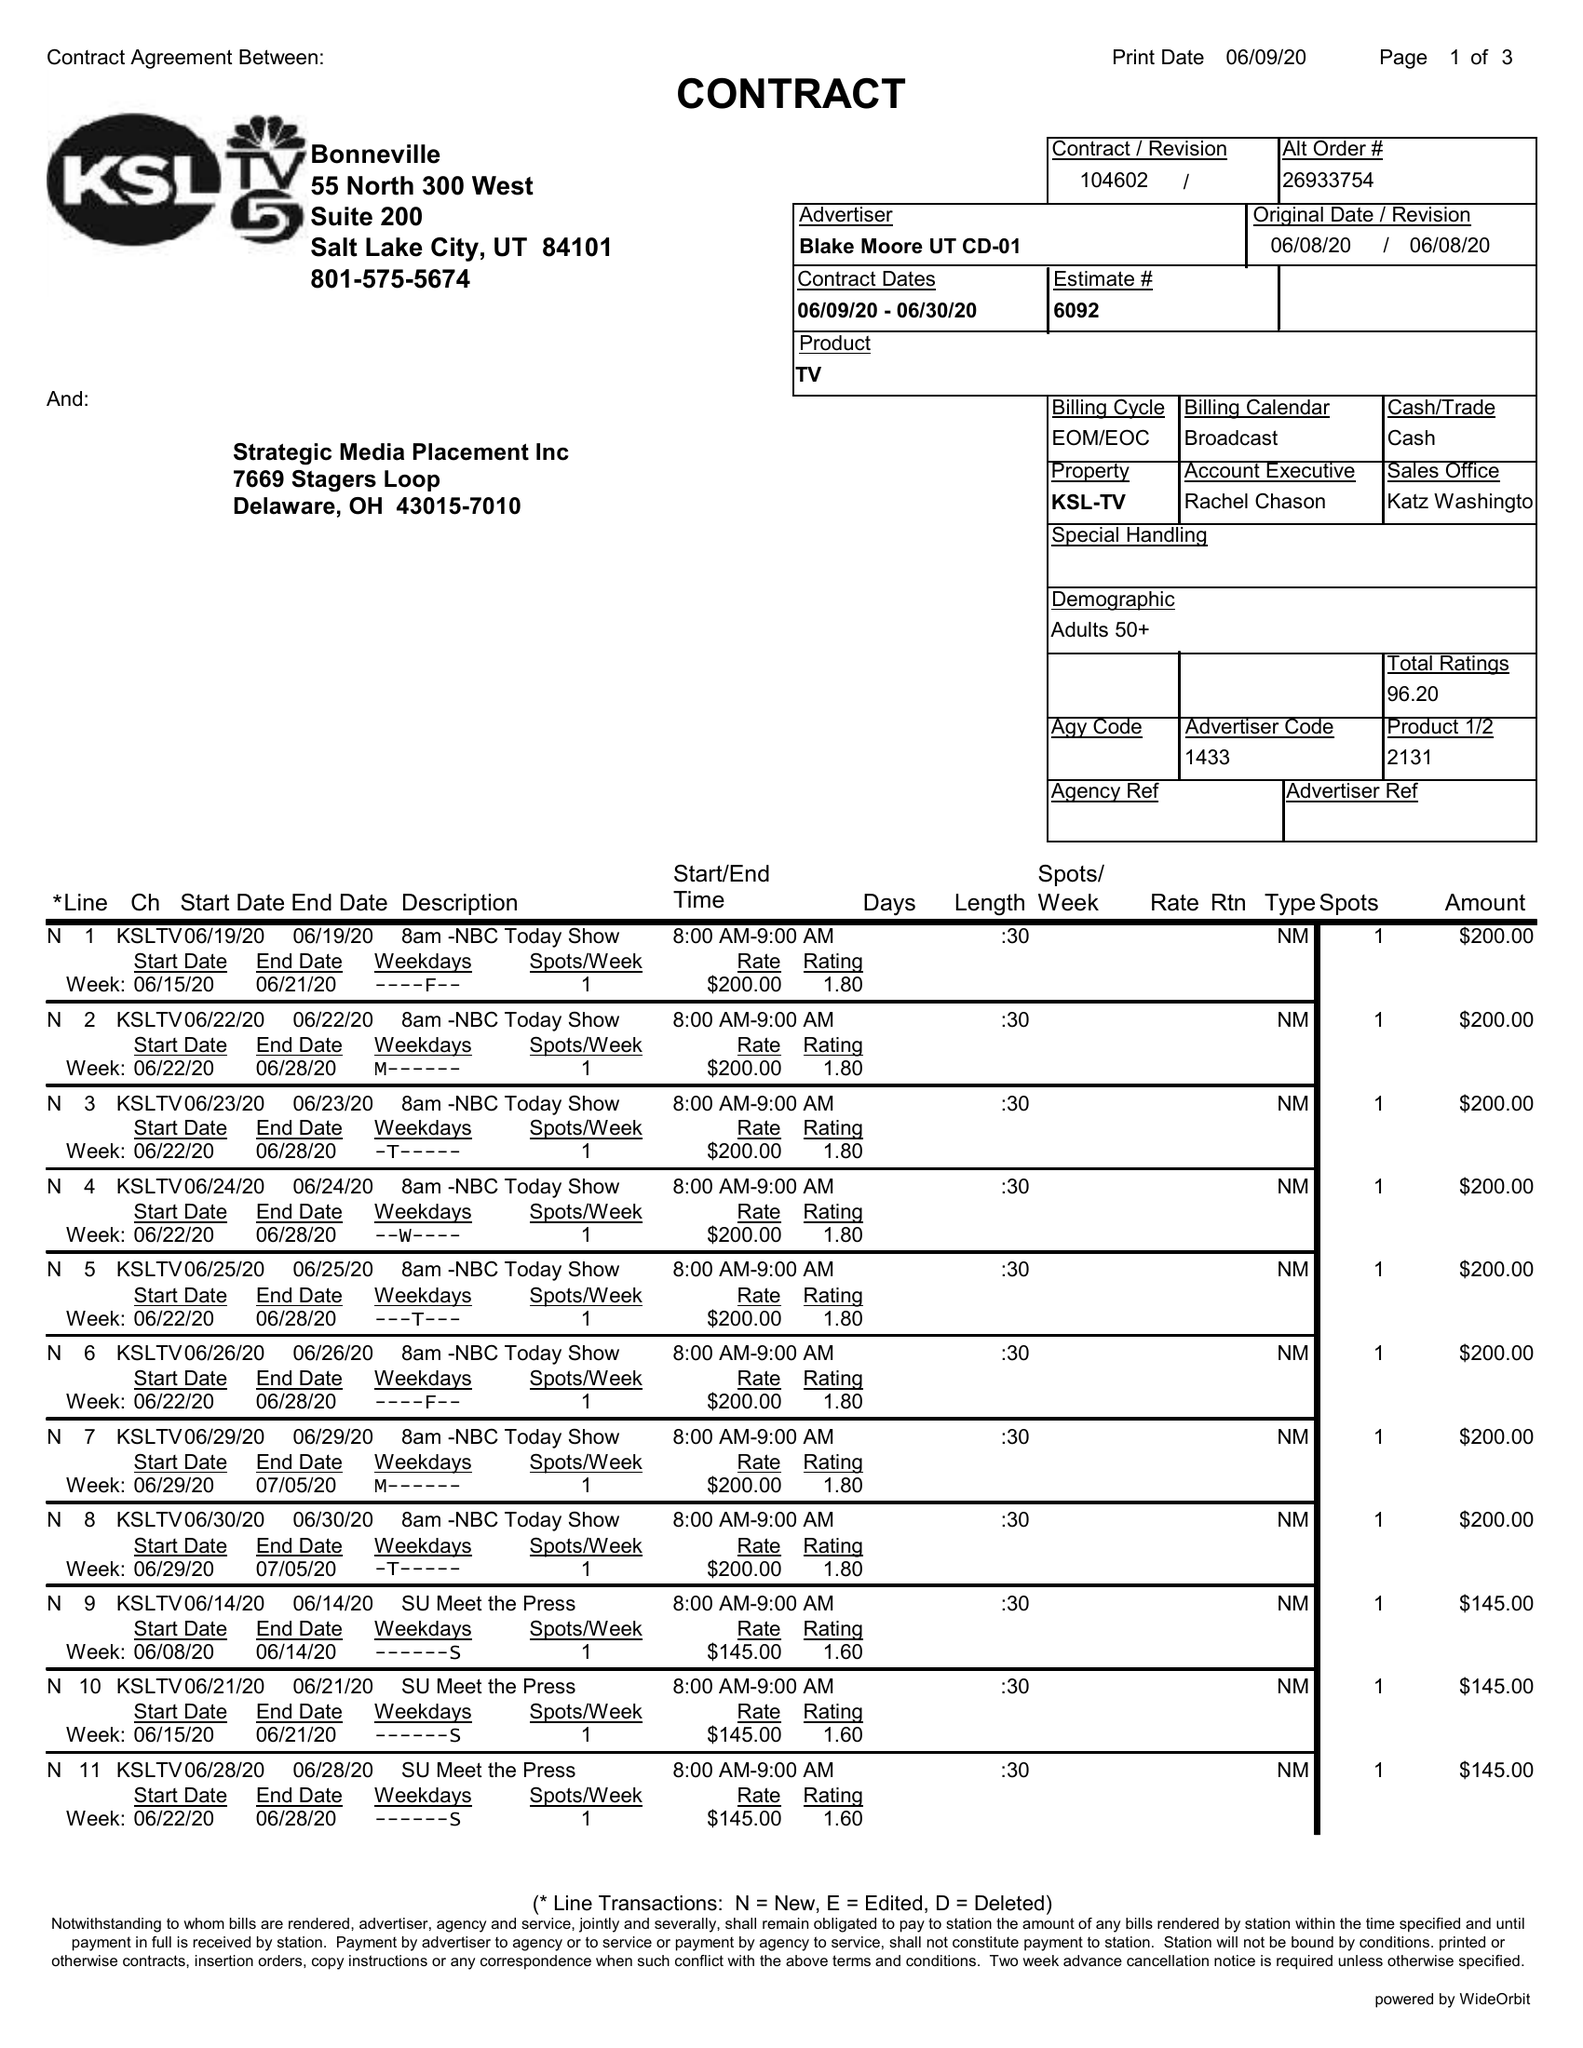What is the value for the flight_from?
Answer the question using a single word or phrase. 06/09/20 